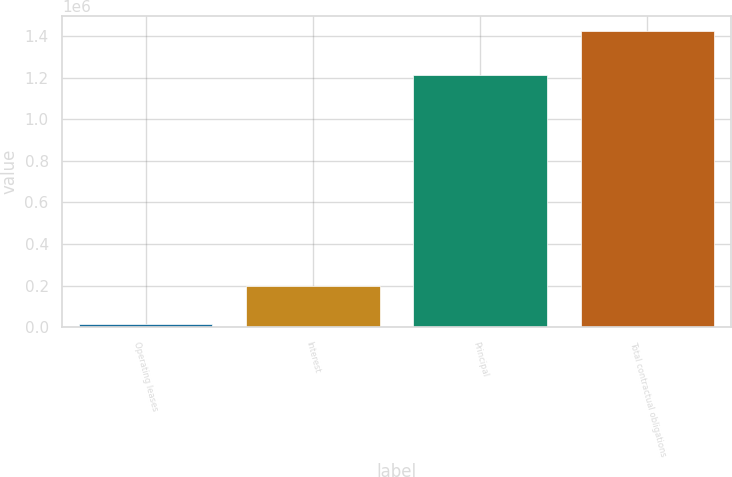<chart> <loc_0><loc_0><loc_500><loc_500><bar_chart><fcel>Operating leases<fcel>Interest<fcel>Principal<fcel>Total contractual obligations<nl><fcel>14858<fcel>198755<fcel>1.21059e+06<fcel>1.42421e+06<nl></chart> 